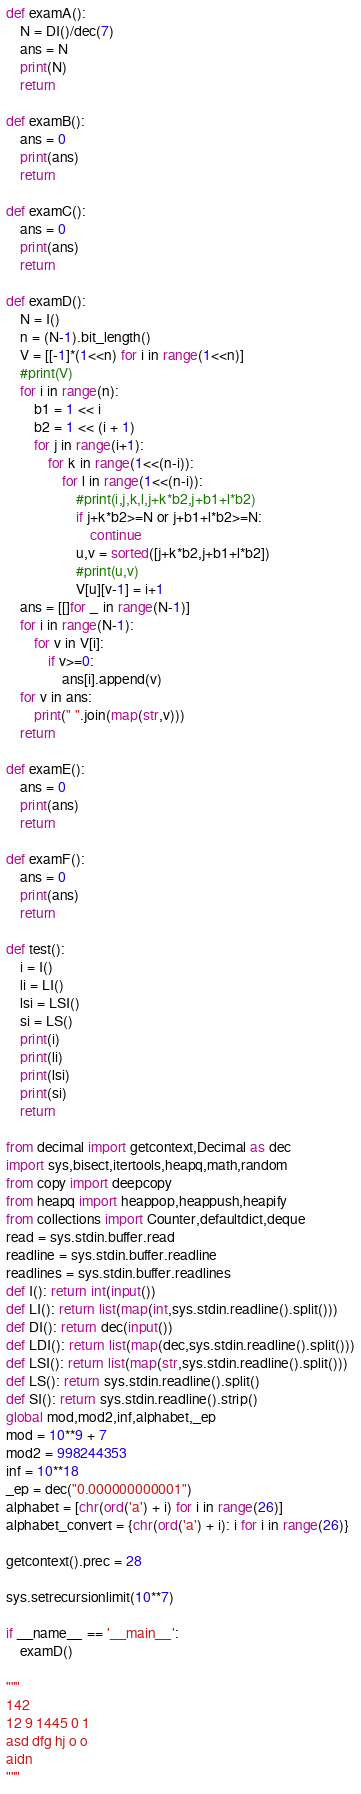<code> <loc_0><loc_0><loc_500><loc_500><_Python_>def examA():
    N = DI()/dec(7)
    ans = N
    print(N)
    return

def examB():
    ans = 0
    print(ans)
    return

def examC():
    ans = 0
    print(ans)
    return

def examD():
    N = I()
    n = (N-1).bit_length()
    V = [[-1]*(1<<n) for i in range(1<<n)]
    #print(V)
    for i in range(n):
        b1 = 1 << i
        b2 = 1 << (i + 1)
        for j in range(i+1):
            for k in range(1<<(n-i)):
                for l in range(1<<(n-i)):
                    #print(i,j,k,l,j+k*b2,j+b1+l*b2)
                    if j+k*b2>=N or j+b1+l*b2>=N:
                        continue
                    u,v = sorted([j+k*b2,j+b1+l*b2])
                    #print(u,v)
                    V[u][v-1] = i+1
    ans = [[]for _ in range(N-1)]
    for i in range(N-1):
        for v in V[i]:
            if v>=0:
                ans[i].append(v)
    for v in ans:
        print(" ".join(map(str,v)))
    return

def examE():
    ans = 0
    print(ans)
    return

def examF():
    ans = 0
    print(ans)
    return

def test():
    i = I()
    li = LI()
    lsi = LSI()
    si = LS()
    print(i)
    print(li)
    print(lsi)
    print(si)
    return

from decimal import getcontext,Decimal as dec
import sys,bisect,itertools,heapq,math,random
from copy import deepcopy
from heapq import heappop,heappush,heapify
from collections import Counter,defaultdict,deque
read = sys.stdin.buffer.read
readline = sys.stdin.buffer.readline
readlines = sys.stdin.buffer.readlines
def I(): return int(input())
def LI(): return list(map(int,sys.stdin.readline().split()))
def DI(): return dec(input())
def LDI(): return list(map(dec,sys.stdin.readline().split()))
def LSI(): return list(map(str,sys.stdin.readline().split()))
def LS(): return sys.stdin.readline().split()
def SI(): return sys.stdin.readline().strip()
global mod,mod2,inf,alphabet,_ep
mod = 10**9 + 7
mod2 = 998244353
inf = 10**18
_ep = dec("0.000000000001")
alphabet = [chr(ord('a') + i) for i in range(26)]
alphabet_convert = {chr(ord('a') + i): i for i in range(26)}

getcontext().prec = 28

sys.setrecursionlimit(10**7)

if __name__ == '__main__':
    examD()

"""
142
12 9 1445 0 1
asd dfg hj o o
aidn
"""</code> 